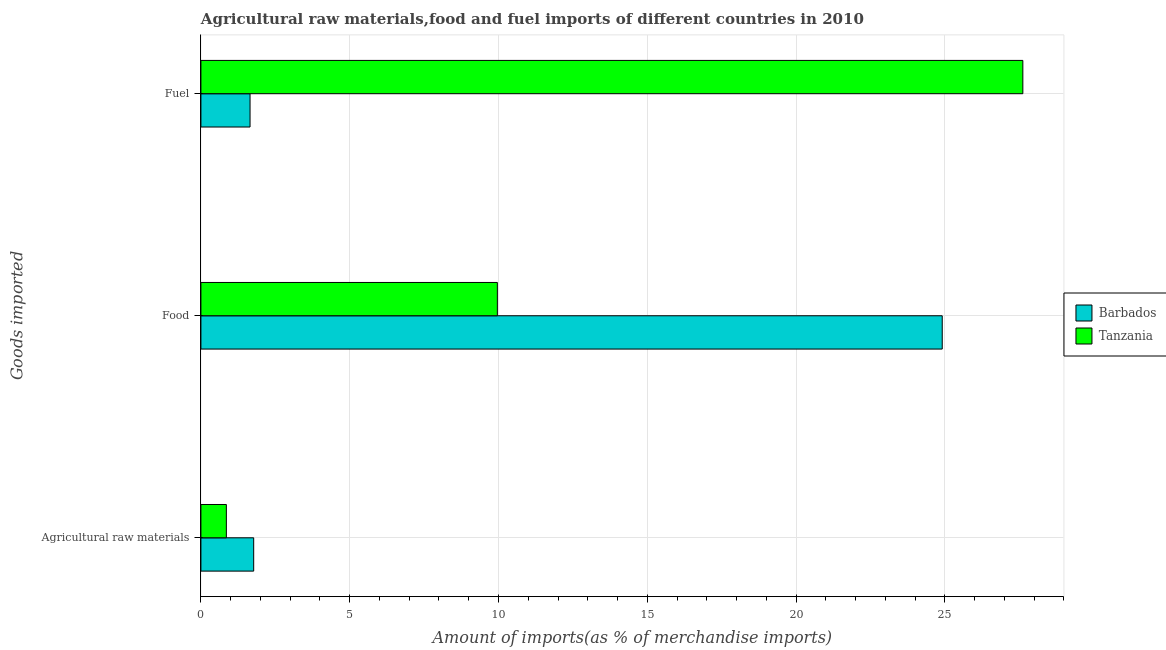How many different coloured bars are there?
Ensure brevity in your answer.  2. Are the number of bars per tick equal to the number of legend labels?
Your answer should be very brief. Yes. Are the number of bars on each tick of the Y-axis equal?
Keep it short and to the point. Yes. What is the label of the 2nd group of bars from the top?
Ensure brevity in your answer.  Food. What is the percentage of food imports in Tanzania?
Keep it short and to the point. 9.96. Across all countries, what is the maximum percentage of raw materials imports?
Provide a short and direct response. 1.77. Across all countries, what is the minimum percentage of food imports?
Make the answer very short. 9.96. In which country was the percentage of food imports maximum?
Make the answer very short. Barbados. In which country was the percentage of fuel imports minimum?
Offer a very short reply. Barbados. What is the total percentage of raw materials imports in the graph?
Provide a short and direct response. 2.63. What is the difference between the percentage of raw materials imports in Tanzania and that in Barbados?
Provide a succinct answer. -0.92. What is the difference between the percentage of fuel imports in Tanzania and the percentage of food imports in Barbados?
Ensure brevity in your answer.  2.71. What is the average percentage of raw materials imports per country?
Offer a very short reply. 1.31. What is the difference between the percentage of food imports and percentage of raw materials imports in Tanzania?
Provide a short and direct response. 9.11. In how many countries, is the percentage of fuel imports greater than 1 %?
Offer a terse response. 2. What is the ratio of the percentage of fuel imports in Barbados to that in Tanzania?
Your response must be concise. 0.06. Is the difference between the percentage of fuel imports in Barbados and Tanzania greater than the difference between the percentage of food imports in Barbados and Tanzania?
Provide a short and direct response. No. What is the difference between the highest and the second highest percentage of fuel imports?
Provide a short and direct response. 25.97. What is the difference between the highest and the lowest percentage of raw materials imports?
Offer a terse response. 0.92. Is the sum of the percentage of food imports in Tanzania and Barbados greater than the maximum percentage of raw materials imports across all countries?
Ensure brevity in your answer.  Yes. What does the 1st bar from the top in Fuel represents?
Make the answer very short. Tanzania. What does the 2nd bar from the bottom in Fuel represents?
Make the answer very short. Tanzania. What is the difference between two consecutive major ticks on the X-axis?
Your response must be concise. 5. Does the graph contain any zero values?
Offer a terse response. No. Does the graph contain grids?
Make the answer very short. Yes. Where does the legend appear in the graph?
Provide a short and direct response. Center right. How many legend labels are there?
Keep it short and to the point. 2. What is the title of the graph?
Offer a terse response. Agricultural raw materials,food and fuel imports of different countries in 2010. What is the label or title of the X-axis?
Your answer should be compact. Amount of imports(as % of merchandise imports). What is the label or title of the Y-axis?
Make the answer very short. Goods imported. What is the Amount of imports(as % of merchandise imports) of Barbados in Agricultural raw materials?
Provide a succinct answer. 1.77. What is the Amount of imports(as % of merchandise imports) in Tanzania in Agricultural raw materials?
Keep it short and to the point. 0.86. What is the Amount of imports(as % of merchandise imports) of Barbados in Food?
Offer a terse response. 24.91. What is the Amount of imports(as % of merchandise imports) in Tanzania in Food?
Give a very brief answer. 9.96. What is the Amount of imports(as % of merchandise imports) of Barbados in Fuel?
Provide a succinct answer. 1.65. What is the Amount of imports(as % of merchandise imports) in Tanzania in Fuel?
Offer a terse response. 27.62. Across all Goods imported, what is the maximum Amount of imports(as % of merchandise imports) of Barbados?
Provide a succinct answer. 24.91. Across all Goods imported, what is the maximum Amount of imports(as % of merchandise imports) of Tanzania?
Offer a terse response. 27.62. Across all Goods imported, what is the minimum Amount of imports(as % of merchandise imports) of Barbados?
Make the answer very short. 1.65. Across all Goods imported, what is the minimum Amount of imports(as % of merchandise imports) in Tanzania?
Make the answer very short. 0.86. What is the total Amount of imports(as % of merchandise imports) of Barbados in the graph?
Your response must be concise. 28.33. What is the total Amount of imports(as % of merchandise imports) in Tanzania in the graph?
Give a very brief answer. 38.44. What is the difference between the Amount of imports(as % of merchandise imports) in Barbados in Agricultural raw materials and that in Food?
Make the answer very short. -23.14. What is the difference between the Amount of imports(as % of merchandise imports) of Tanzania in Agricultural raw materials and that in Food?
Keep it short and to the point. -9.11. What is the difference between the Amount of imports(as % of merchandise imports) in Barbados in Agricultural raw materials and that in Fuel?
Your answer should be compact. 0.12. What is the difference between the Amount of imports(as % of merchandise imports) in Tanzania in Agricultural raw materials and that in Fuel?
Provide a short and direct response. -26.76. What is the difference between the Amount of imports(as % of merchandise imports) in Barbados in Food and that in Fuel?
Offer a very short reply. 23.26. What is the difference between the Amount of imports(as % of merchandise imports) in Tanzania in Food and that in Fuel?
Your answer should be very brief. -17.66. What is the difference between the Amount of imports(as % of merchandise imports) of Barbados in Agricultural raw materials and the Amount of imports(as % of merchandise imports) of Tanzania in Food?
Your answer should be very brief. -8.19. What is the difference between the Amount of imports(as % of merchandise imports) in Barbados in Agricultural raw materials and the Amount of imports(as % of merchandise imports) in Tanzania in Fuel?
Make the answer very short. -25.85. What is the difference between the Amount of imports(as % of merchandise imports) of Barbados in Food and the Amount of imports(as % of merchandise imports) of Tanzania in Fuel?
Give a very brief answer. -2.71. What is the average Amount of imports(as % of merchandise imports) of Barbados per Goods imported?
Provide a succinct answer. 9.44. What is the average Amount of imports(as % of merchandise imports) of Tanzania per Goods imported?
Keep it short and to the point. 12.81. What is the difference between the Amount of imports(as % of merchandise imports) of Barbados and Amount of imports(as % of merchandise imports) of Tanzania in Agricultural raw materials?
Offer a very short reply. 0.92. What is the difference between the Amount of imports(as % of merchandise imports) in Barbados and Amount of imports(as % of merchandise imports) in Tanzania in Food?
Your response must be concise. 14.95. What is the difference between the Amount of imports(as % of merchandise imports) in Barbados and Amount of imports(as % of merchandise imports) in Tanzania in Fuel?
Give a very brief answer. -25.97. What is the ratio of the Amount of imports(as % of merchandise imports) in Barbados in Agricultural raw materials to that in Food?
Your response must be concise. 0.07. What is the ratio of the Amount of imports(as % of merchandise imports) in Tanzania in Agricultural raw materials to that in Food?
Your answer should be compact. 0.09. What is the ratio of the Amount of imports(as % of merchandise imports) of Barbados in Agricultural raw materials to that in Fuel?
Your response must be concise. 1.07. What is the ratio of the Amount of imports(as % of merchandise imports) in Tanzania in Agricultural raw materials to that in Fuel?
Ensure brevity in your answer.  0.03. What is the ratio of the Amount of imports(as % of merchandise imports) of Barbados in Food to that in Fuel?
Ensure brevity in your answer.  15.09. What is the ratio of the Amount of imports(as % of merchandise imports) of Tanzania in Food to that in Fuel?
Ensure brevity in your answer.  0.36. What is the difference between the highest and the second highest Amount of imports(as % of merchandise imports) of Barbados?
Make the answer very short. 23.14. What is the difference between the highest and the second highest Amount of imports(as % of merchandise imports) of Tanzania?
Your answer should be very brief. 17.66. What is the difference between the highest and the lowest Amount of imports(as % of merchandise imports) in Barbados?
Your response must be concise. 23.26. What is the difference between the highest and the lowest Amount of imports(as % of merchandise imports) in Tanzania?
Make the answer very short. 26.76. 